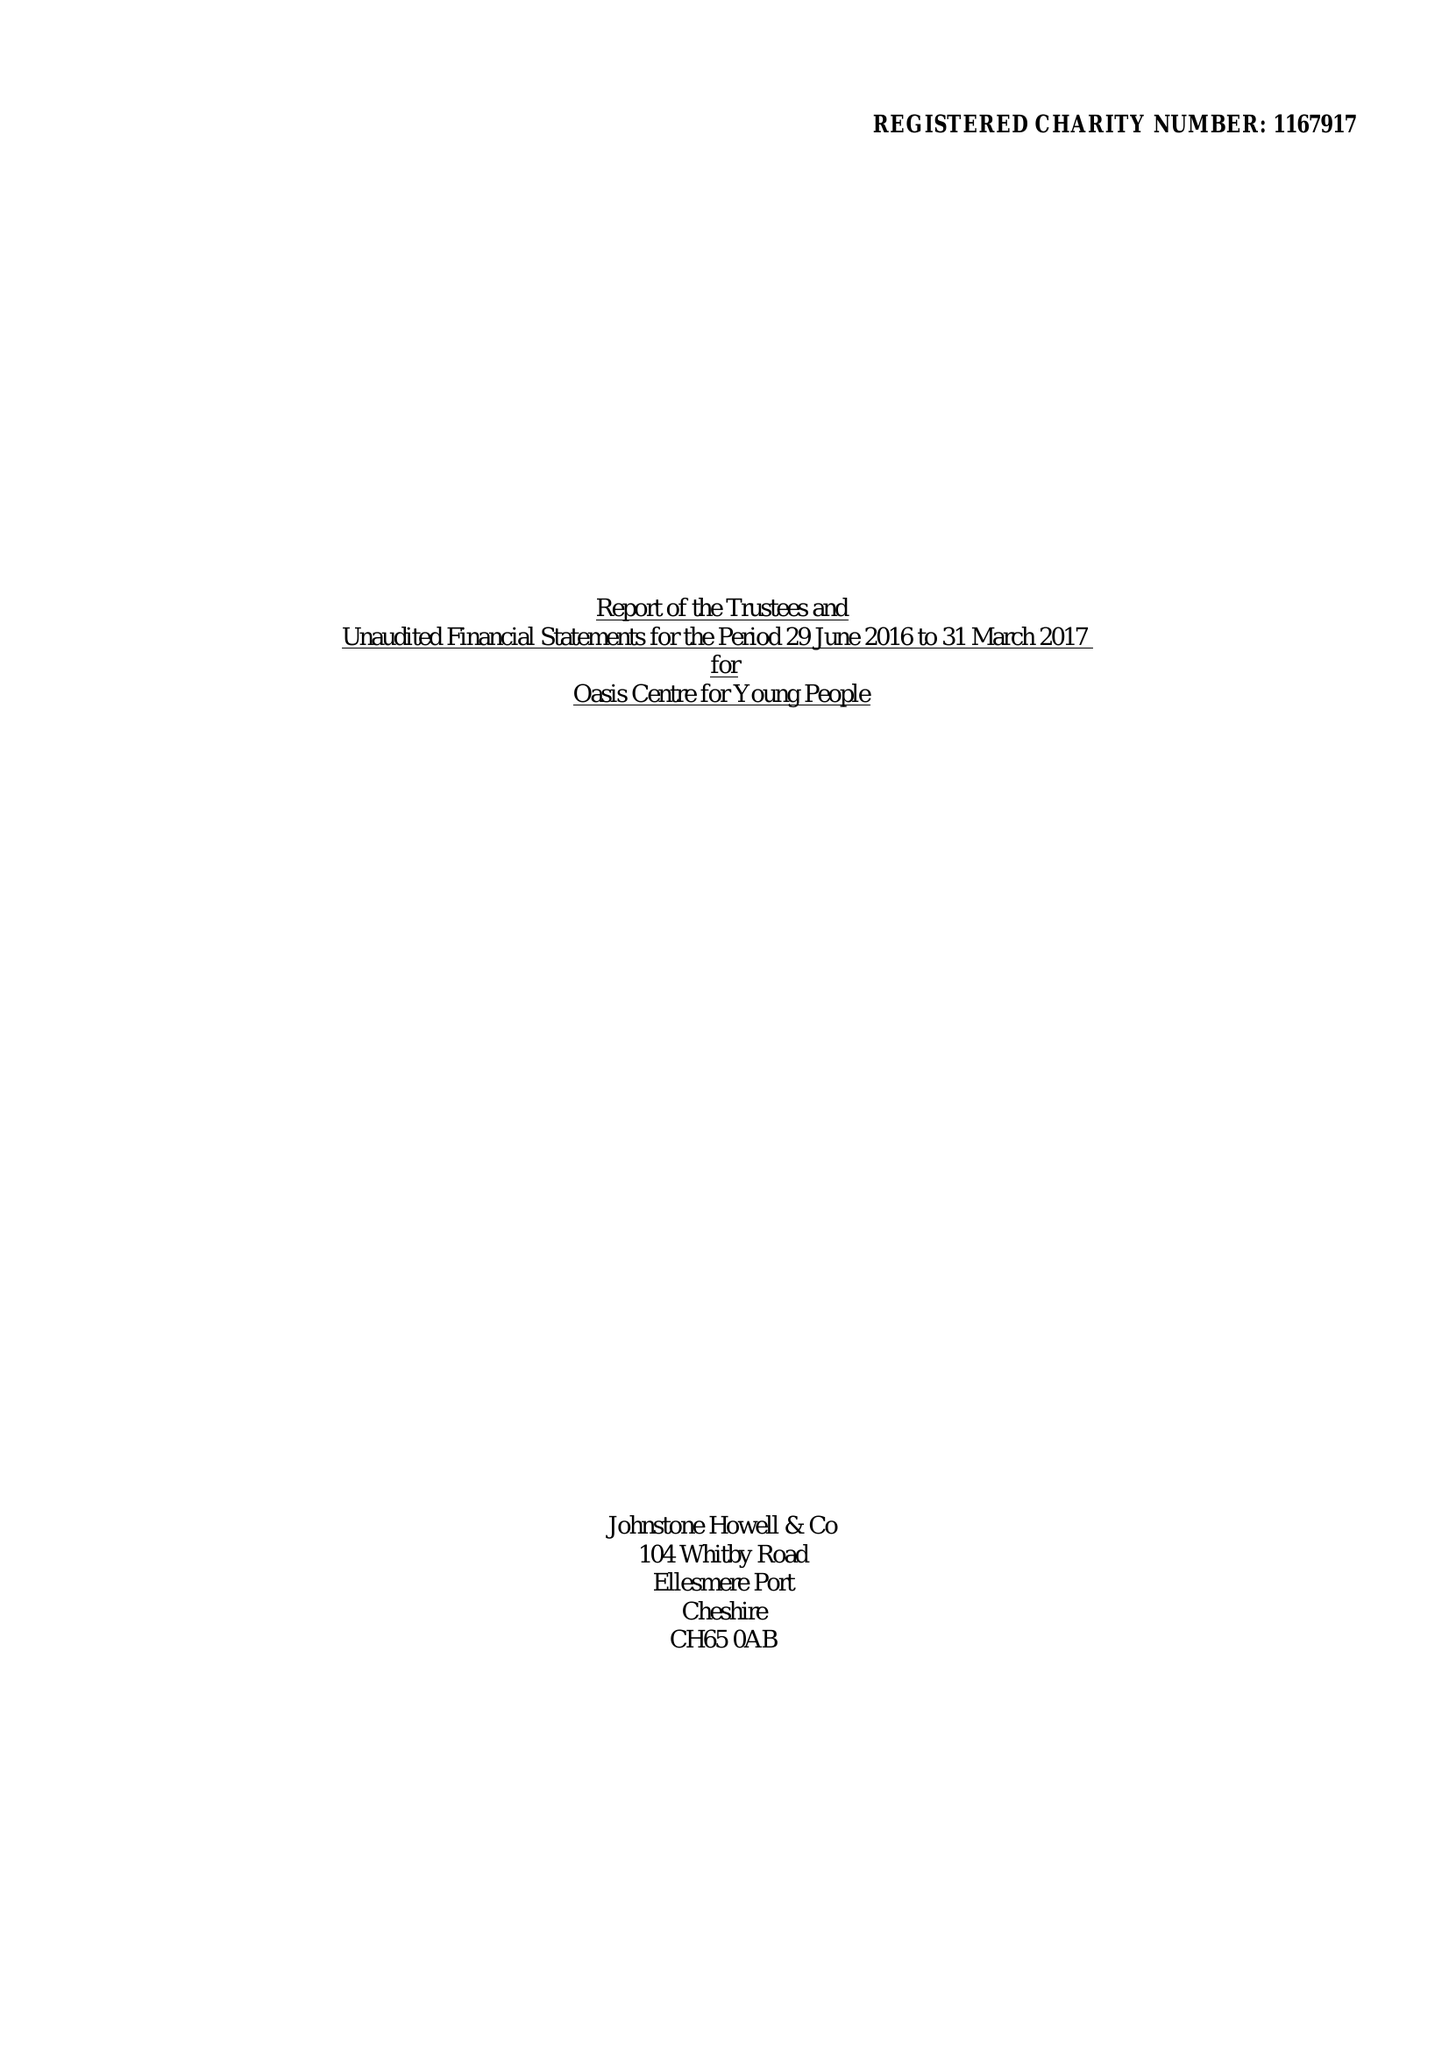What is the value for the charity_name?
Answer the question using a single word or phrase. Oasis Centre For Young People 